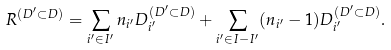Convert formula to latex. <formula><loc_0><loc_0><loc_500><loc_500>R ^ { ( D ^ { \prime } \subset D ) } = \sum _ { i ^ { \prime } \in I ^ { \prime } } n _ { i ^ { \prime } } D _ { i ^ { \prime } } ^ { ( D ^ { \prime } \subset D ) } + \sum _ { i ^ { \prime } \in I - I ^ { \prime } } ( n _ { i ^ { \prime } } - 1 ) D _ { i ^ { \prime } } ^ { ( D ^ { \prime } \subset D ) } .</formula> 